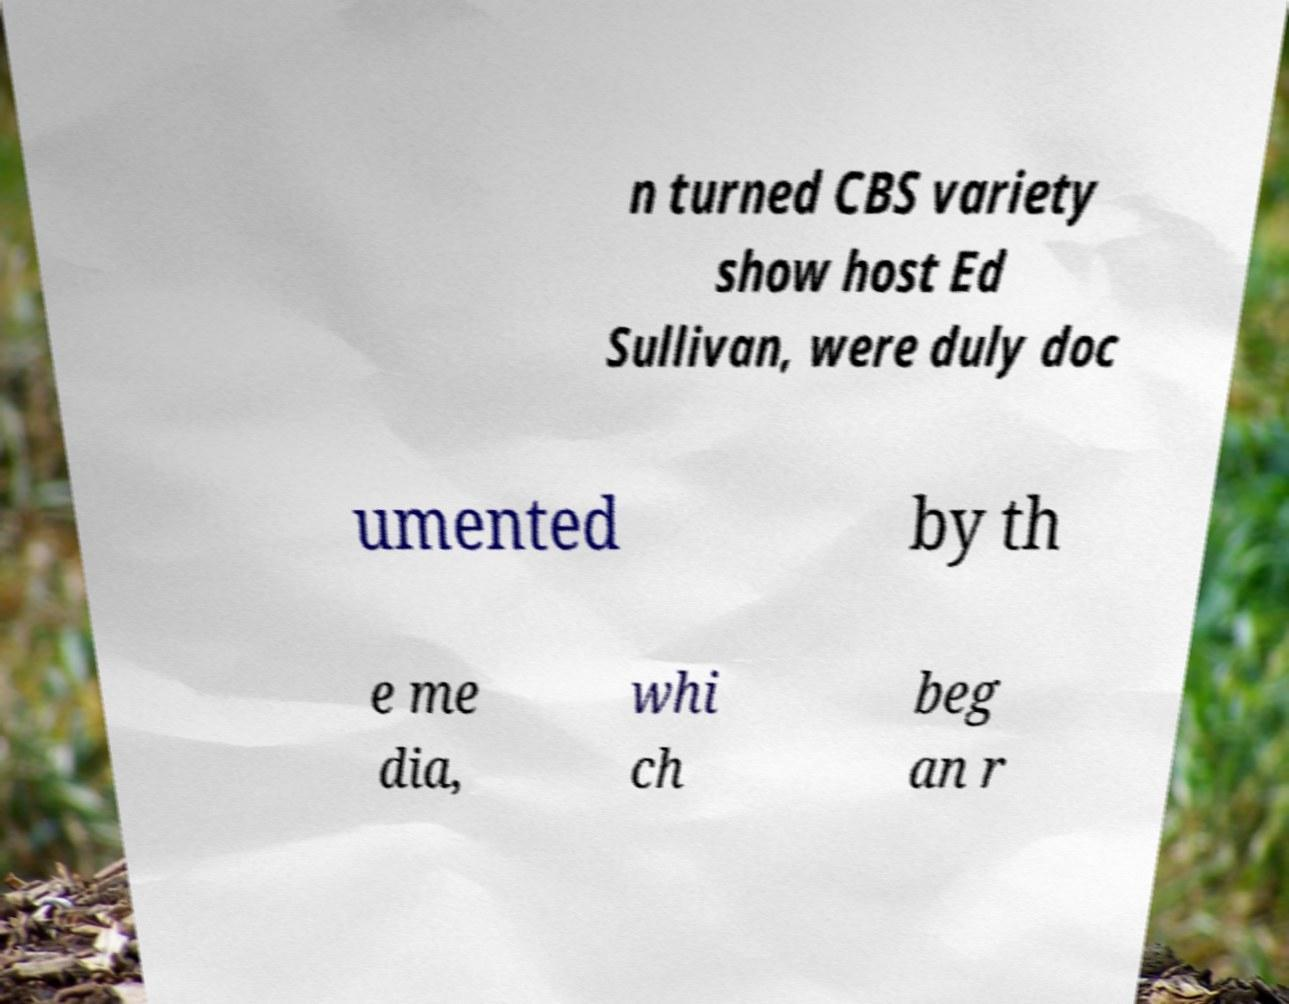Please read and relay the text visible in this image. What does it say? n turned CBS variety show host Ed Sullivan, were duly doc umented by th e me dia, whi ch beg an r 